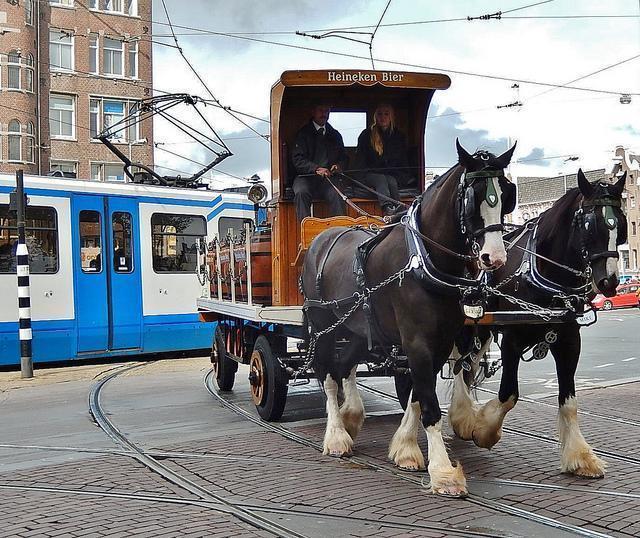What sort of product do ad men use these type horses to market?
Pick the right solution, then justify: 'Answer: answer
Rationale: rationale.'
Options: Horse food, beer, pizza, muffins. Answer: beer.
Rationale: The horses are clydesdales. they are used to market budweiser. 